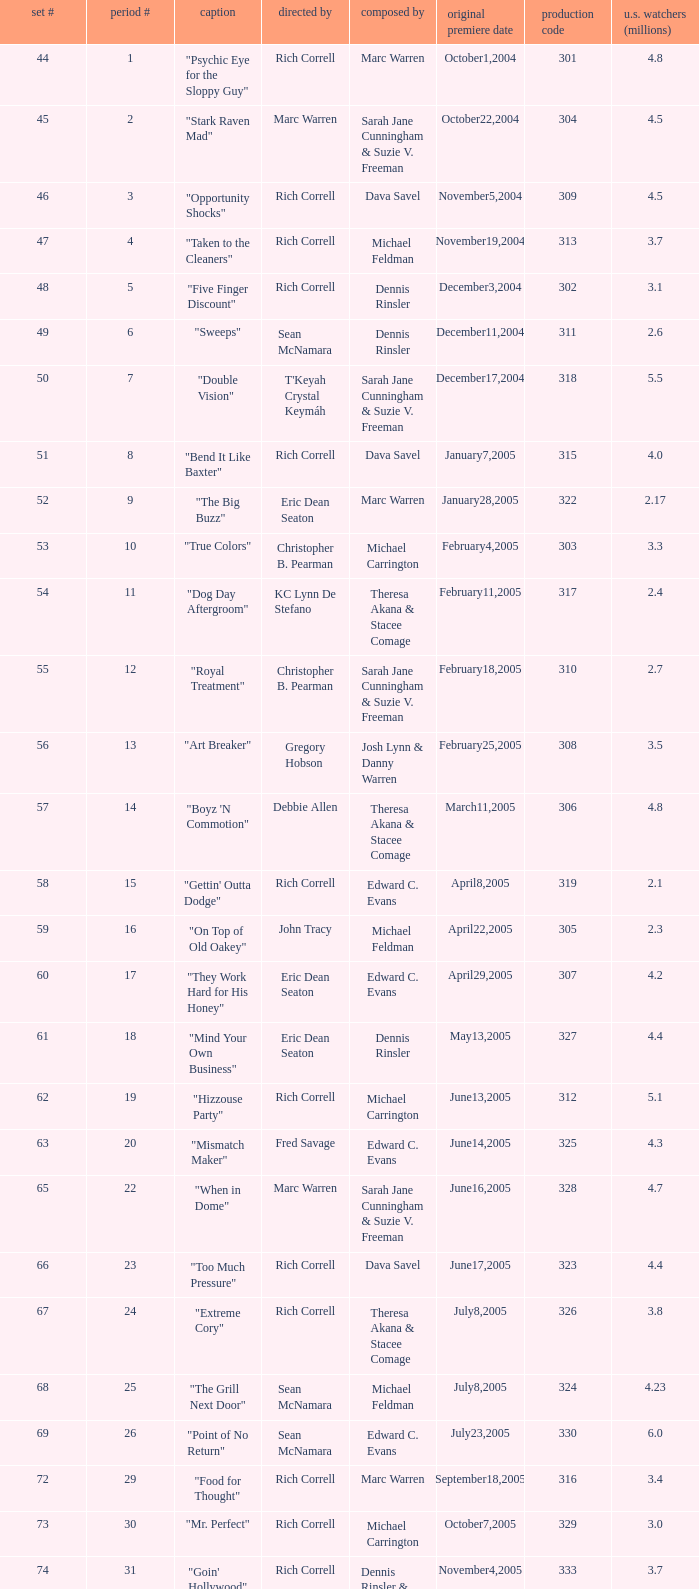What number episode of the season was titled "Vision Impossible"? 34.0. 